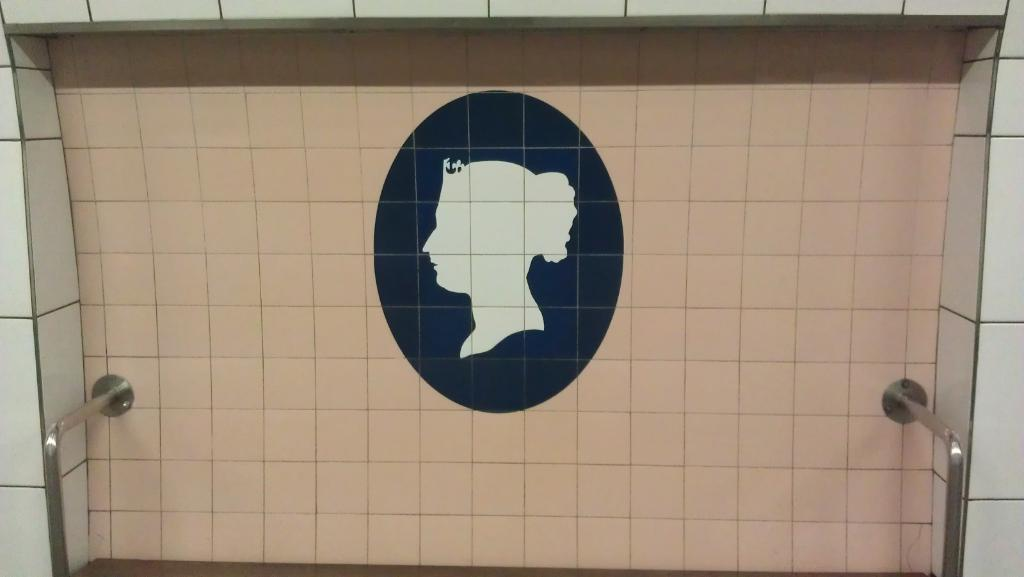What is hanging on the wall in the image? There is a picture on a wall in the image. What type of objects can be seen supporting something in the image? There are metal poles visible in the image. What type of cloud can be seen in the image? There is no cloud present in the image; it only features a picture on a wall and metal poles. How does the truck interact with the metal poles in the image? There is no truck present in the image, so it cannot interact with the metal poles. 